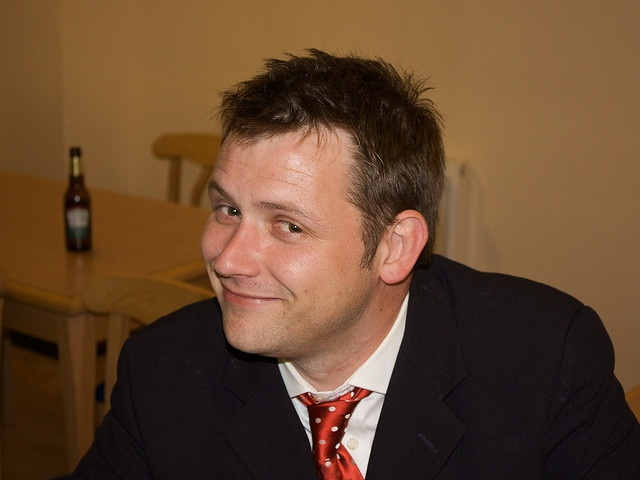Describe the objects in this image and their specific colors. I can see people in maroon, black, brown, salmon, and tan tones, dining table in maroon and black tones, chair in maroon and black tones, tie in maroon, brown, and red tones, and chair in maroon and olive tones in this image. 